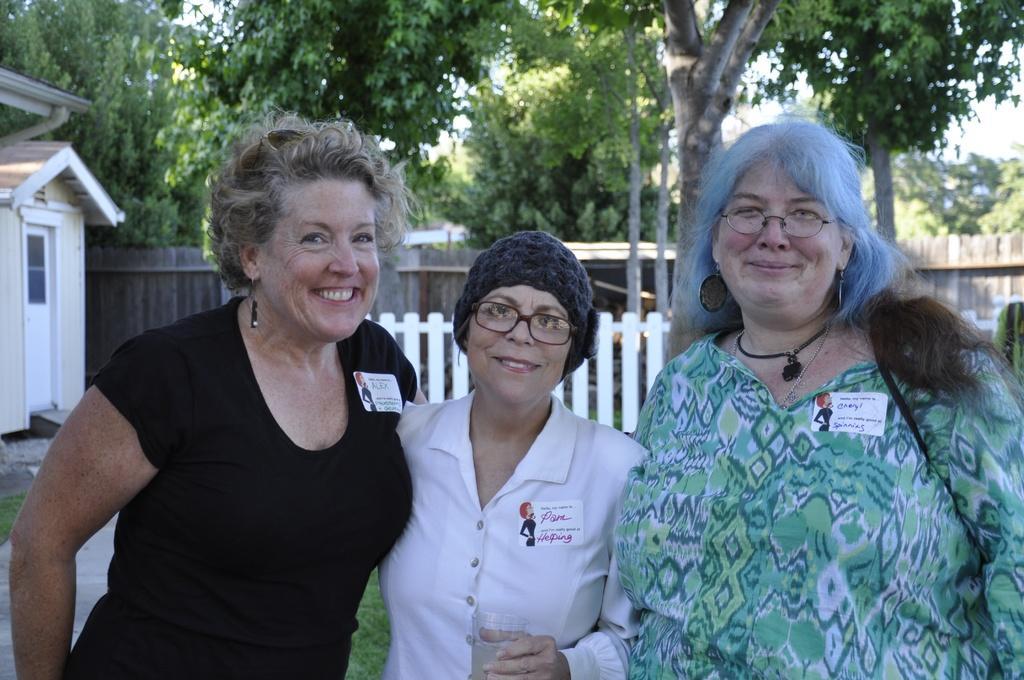Describe this image in one or two sentences. In this image there are three women standing as we can see in middle of this image. the left side person is wearing black color t shirt and the middle one is wearing white color dress and there is a fencing gate in the background which is in white color and there is a house at left side of this image. and There are some trees at top of this image. 